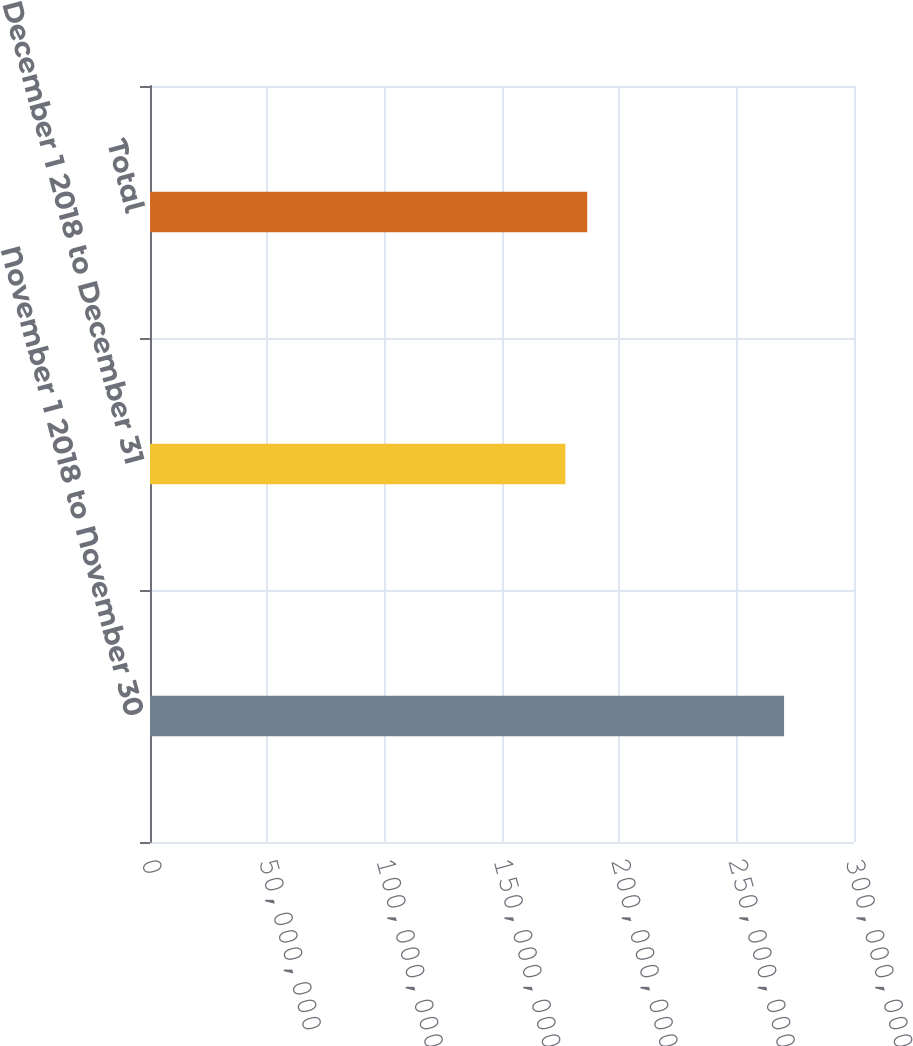<chart> <loc_0><loc_0><loc_500><loc_500><bar_chart><fcel>November 1 2018 to November 30<fcel>December 1 2018 to December 31<fcel>Total<nl><fcel>2.70204e+08<fcel>1.7701e+08<fcel>1.86329e+08<nl></chart> 